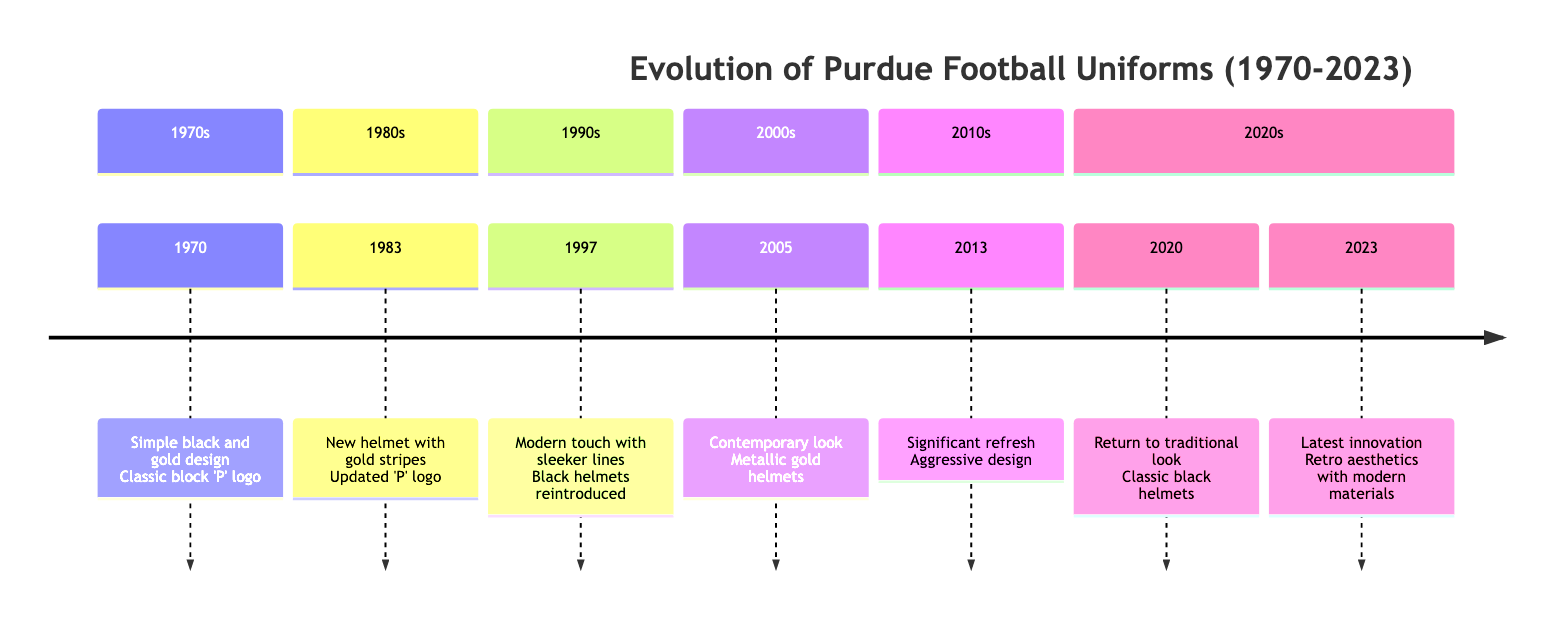What year did Purdue introduce the new helmet design with bold gold stripes? The timeline shows that the new helmet design with bold gold stripes was introduced in 1983. This is clearly indicated in the section labeled "1980s," which lists the event alongside that specific year.
Answer: 1983 What features characterized the 1997 Purdue football uniforms? According to the timeline, the 1997 uniforms included a modern touch with sleeker lines and the reintroduction of black helmets that featured a striking gold 'P' logo. These features are both mentioned in the section labeled "1990s."
Answer: Sleeker lines and black helmets How many significant updates are there in Purdue football uniforms from 1970 to 2023? By reviewing the timeline, you can count the distinct years highlighted for updates or changes to the uniforms, which are: 1970, 1983, 1997, 2005, 2013, 2020, and 2023. This gives us a total of seven different updates.
Answer: 7 What uniform change did Purdue make in 2020? The timeline specifies that the 2020 uniforms represented a return to a traditional look, which is a shift from the more aggressive designs seen in previous years. This detail is mentioned under the section for the year 2020.
Answer: Return to traditional look Which year saw Purdue embracing a contemporary look with metallic gold helmets? The timeline states that in 2005, Purdue embraced a contemporary look that included metallic gold helmets and updated font designs, thus highlighting that year as the time of this significant change.
Answer: 2005 What significant feature was introduced in the 2013 uniforms? In the section for the year 2013, the timeline notes that these uniforms featured new helmet decals and an engineered pattern on the shoulders, indicating a significant design refresh for that year.
Answer: New helmet decals and engineered pattern Between which two years did Purdue make a notable design transition from minimalist to more intricate jersey designs? The timeline shows that the transition began around 1970 with a minimalist style and moved towards intricate designs by 1983, as evidenced by the details provided for those years.
Answer: 1970 to 1983 What is the significance of the 2023 uniforms in terms of athletic wear innovation? According to the timeline, the 2023 uniforms represent the latest in athletic wear innovation by combining retro aesthetics with modern materials, highlighting a blend of historical homage and modern performance.
Answer: Latest in athletic wear innovation 